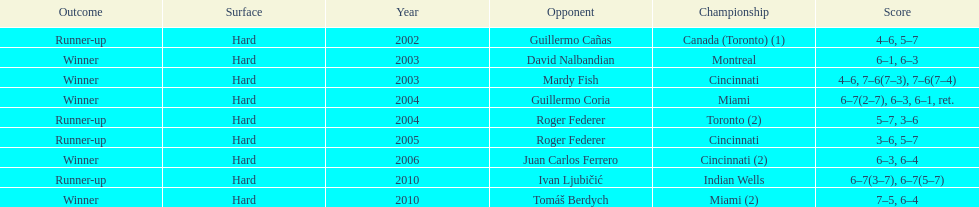How many times was roger federer a runner-up? 2. 